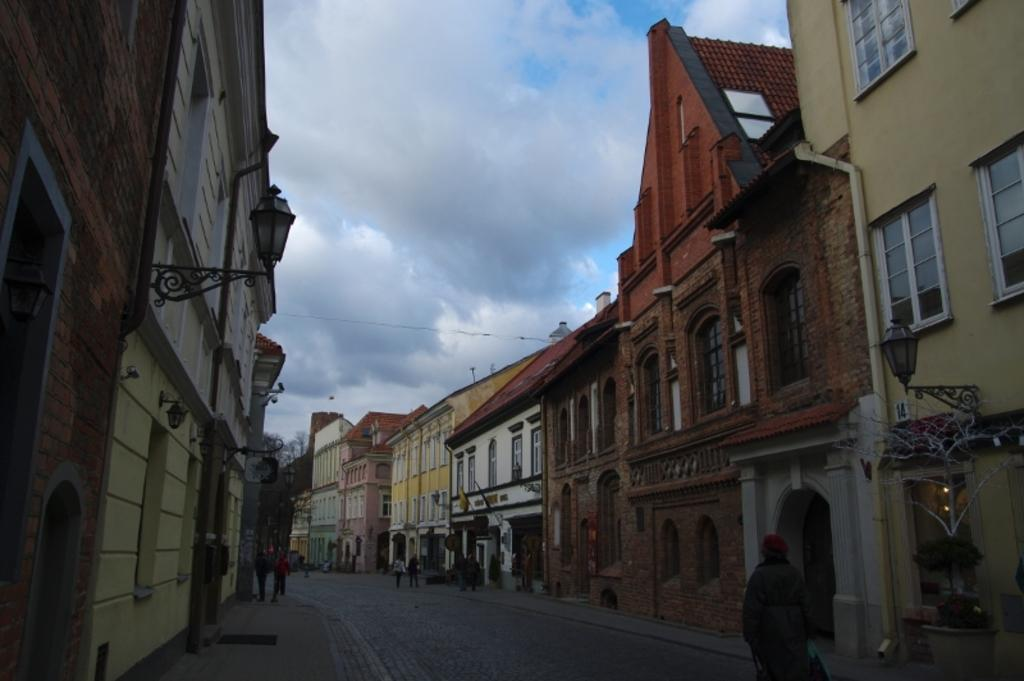What type of structures can be seen in the image? There are many buildings in the image. What feature do the buildings have? The buildings have windows. What is located at the bottom of the image? There is a road at the bottom of the image. Who or what can be seen in the image? There are people visible in the image. What is visible in the sky in the image? There are clouds visible at the top of the image. How many eggs are being whipped in the image? There are no eggs or whipping activity present in the image. 